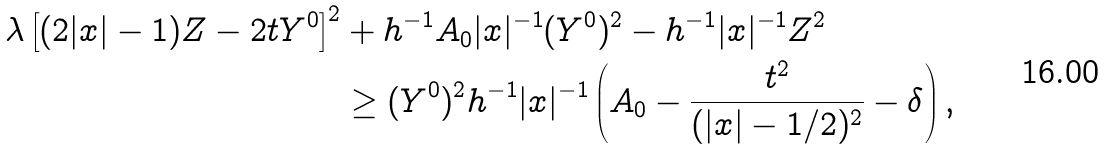<formula> <loc_0><loc_0><loc_500><loc_500>\lambda \left [ ( 2 | x | - 1 ) Z - 2 t Y ^ { 0 } \right ] ^ { 2 } & + h ^ { - 1 } A _ { 0 } | x | ^ { - 1 } ( Y ^ { 0 } ) ^ { 2 } - h ^ { - 1 } | x | ^ { - 1 } Z ^ { 2 } \\ & \geq ( Y ^ { 0 } ) ^ { 2 } h ^ { - 1 } | x | ^ { - 1 } \left ( A _ { 0 } - \frac { t ^ { 2 } } { ( | x | - 1 / 2 ) ^ { 2 } } - \delta \right ) ,</formula> 